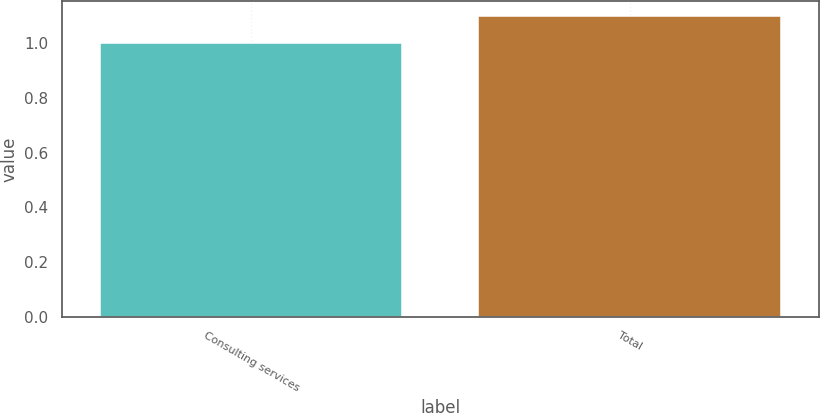Convert chart to OTSL. <chart><loc_0><loc_0><loc_500><loc_500><bar_chart><fcel>Consulting services<fcel>Total<nl><fcel>1<fcel>1.1<nl></chart> 